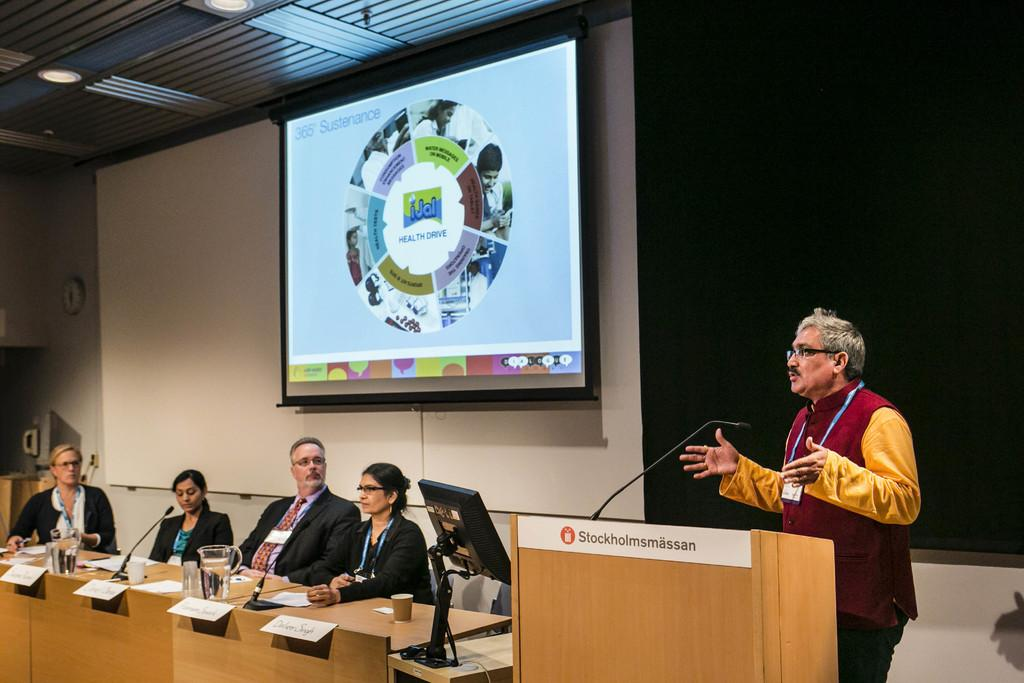How many people are present in the image? There are four people sitting in the image. What is the person in front doing? The person in front is standing in front of a podium. What is the podium used for in the image? The podium is used for the person to stand in front of while addressing the audience. What is located at the back of the scene? There is a screen at the back of the scene. What type of rhythm is the stove producing in the image? There is no stove present in the image, so it cannot produce any rhythm. 